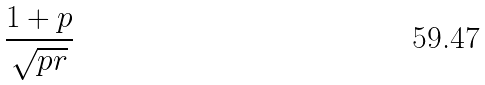Convert formula to latex. <formula><loc_0><loc_0><loc_500><loc_500>\frac { 1 + p } { \sqrt { p r } }</formula> 